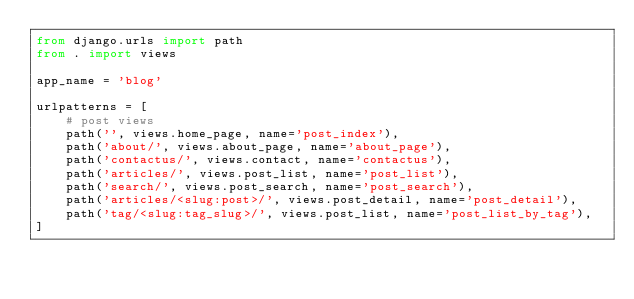Convert code to text. <code><loc_0><loc_0><loc_500><loc_500><_Python_>from django.urls import path
from . import views

app_name = 'blog'

urlpatterns = [
    # post views
    path('', views.home_page, name='post_index'),
    path('about/', views.about_page, name='about_page'),
    path('contactus/', views.contact, name='contactus'),
    path('articles/', views.post_list, name='post_list'),
    path('search/', views.post_search, name='post_search'),
    path('articles/<slug:post>/', views.post_detail, name='post_detail'),
    path('tag/<slug:tag_slug>/', views.post_list, name='post_list_by_tag'),
]
</code> 